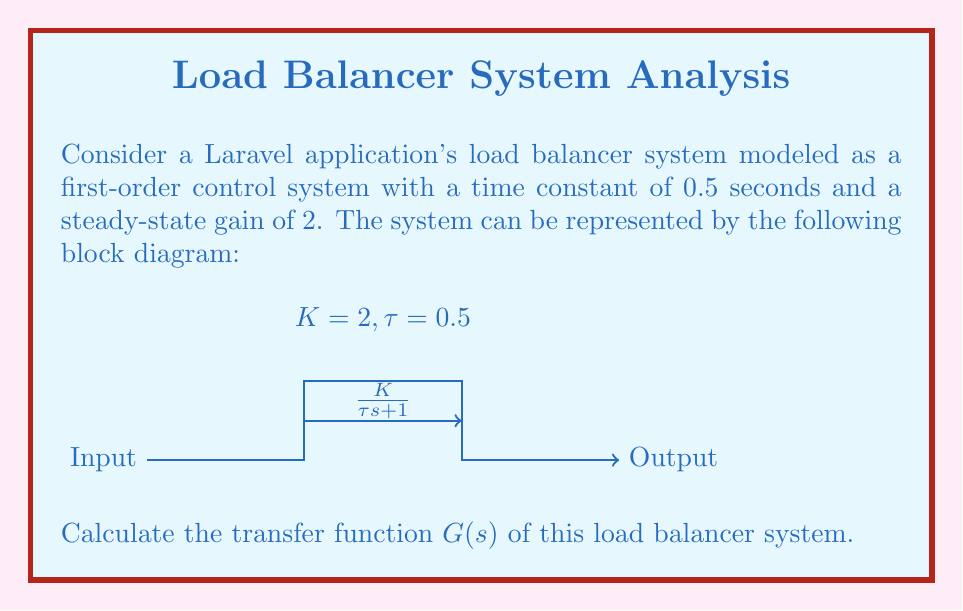What is the answer to this math problem? To calculate the transfer function of the given first-order control system, we'll follow these steps:

1) The general form of a first-order transfer function is:

   $$G(s) = \frac{K}{\tau s + 1}$$

   where $K$ is the steady-state gain and $\tau$ is the time constant.

2) From the given information:
   - Steady-state gain, $K = 2$
   - Time constant, $\tau = 0.5$ seconds

3) Substituting these values into the general form:

   $$G(s) = \frac{2}{0.5s + 1}$$

4) To simplify, we can factor out the time constant from the denominator:

   $$G(s) = \frac{2}{0.5(s + \frac{1}{0.5})}$$

5) Simplify further:

   $$G(s) = \frac{2}{0.5(s + 2)}$$

6) Finally, divide both numerator and denominator by 0.5:

   $$G(s) = \frac{4}{s + 2}$$

This is the simplified transfer function of the load balancer system.
Answer: $$G(s) = \frac{4}{s + 2}$$ 